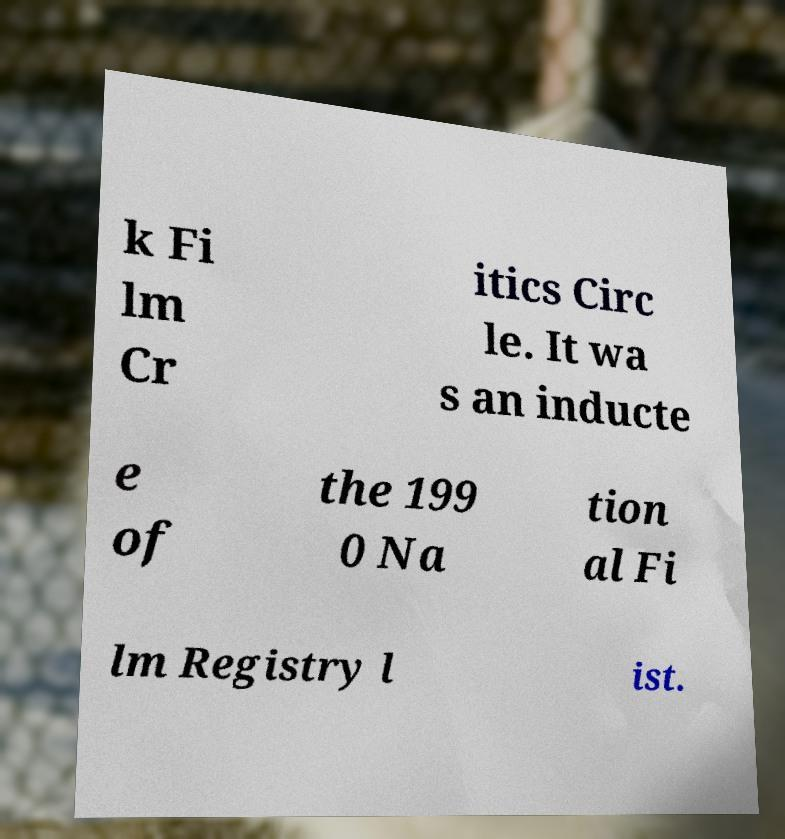What messages or text are displayed in this image? I need them in a readable, typed format. k Fi lm Cr itics Circ le. It wa s an inducte e of the 199 0 Na tion al Fi lm Registry l ist. 